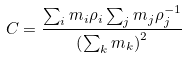<formula> <loc_0><loc_0><loc_500><loc_500>C = \frac { \sum _ { i } m _ { i } \rho _ { i } \sum _ { j } m _ { j } \rho _ { j } ^ { - 1 } } { \left ( \sum _ { k } m _ { k } \right ) ^ { 2 } }</formula> 